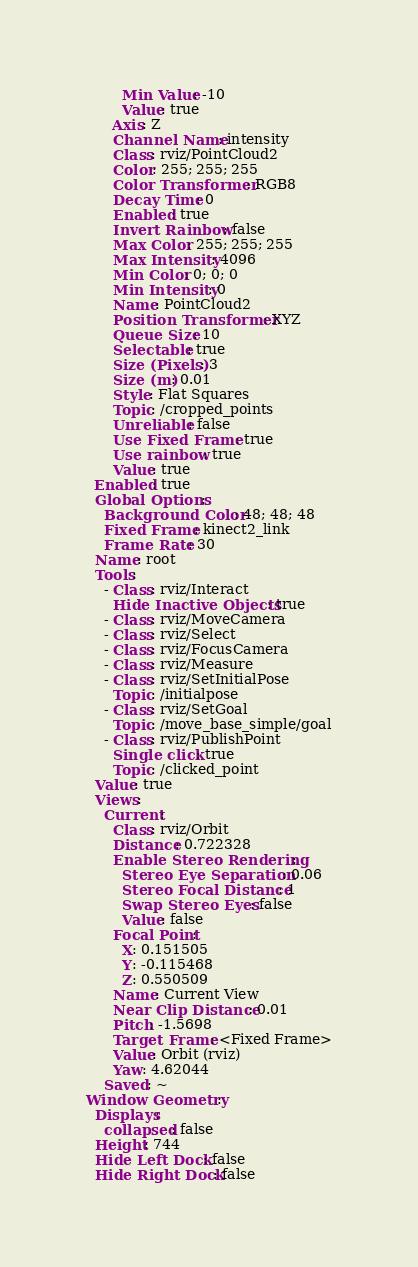Convert code to text. <code><loc_0><loc_0><loc_500><loc_500><_YAML_>        Min Value: -10
        Value: true
      Axis: Z
      Channel Name: intensity
      Class: rviz/PointCloud2
      Color: 255; 255; 255
      Color Transformer: RGB8
      Decay Time: 0
      Enabled: true
      Invert Rainbow: false
      Max Color: 255; 255; 255
      Max Intensity: 4096
      Min Color: 0; 0; 0
      Min Intensity: 0
      Name: PointCloud2
      Position Transformer: XYZ
      Queue Size: 10
      Selectable: true
      Size (Pixels): 3
      Size (m): 0.01
      Style: Flat Squares
      Topic: /cropped_points
      Unreliable: false
      Use Fixed Frame: true
      Use rainbow: true
      Value: true
  Enabled: true
  Global Options:
    Background Color: 48; 48; 48
    Fixed Frame: kinect2_link
    Frame Rate: 30
  Name: root
  Tools:
    - Class: rviz/Interact
      Hide Inactive Objects: true
    - Class: rviz/MoveCamera
    - Class: rviz/Select
    - Class: rviz/FocusCamera
    - Class: rviz/Measure
    - Class: rviz/SetInitialPose
      Topic: /initialpose
    - Class: rviz/SetGoal
      Topic: /move_base_simple/goal
    - Class: rviz/PublishPoint
      Single click: true
      Topic: /clicked_point
  Value: true
  Views:
    Current:
      Class: rviz/Orbit
      Distance: 0.722328
      Enable Stereo Rendering:
        Stereo Eye Separation: 0.06
        Stereo Focal Distance: 1
        Swap Stereo Eyes: false
        Value: false
      Focal Point:
        X: 0.151505
        Y: -0.115468
        Z: 0.550509
      Name: Current View
      Near Clip Distance: 0.01
      Pitch: -1.5698
      Target Frame: <Fixed Frame>
      Value: Orbit (rviz)
      Yaw: 4.62044
    Saved: ~
Window Geometry:
  Displays:
    collapsed: false
  Height: 744
  Hide Left Dock: false
  Hide Right Dock: false</code> 